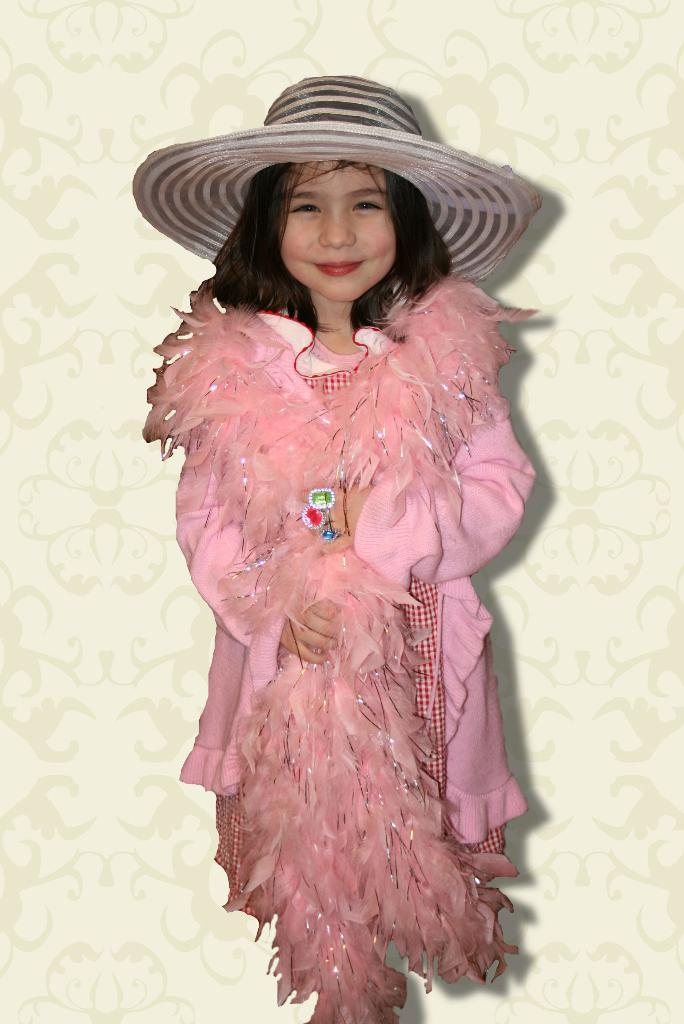Who is the main subject in the image? There is a girl in the image. What is the girl doing in the image? The girl is standing. What is the girl wearing in the image? The girl is wearing a pink dress and a hat. How many visitors are present in the image? There is no mention of visitors in the image, so it cannot be determined how many are present. 